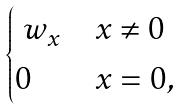Convert formula to latex. <formula><loc_0><loc_0><loc_500><loc_500>\begin{cases} \ w _ { x } & x \neq 0 \\ 0 & x = 0 , \end{cases}</formula> 